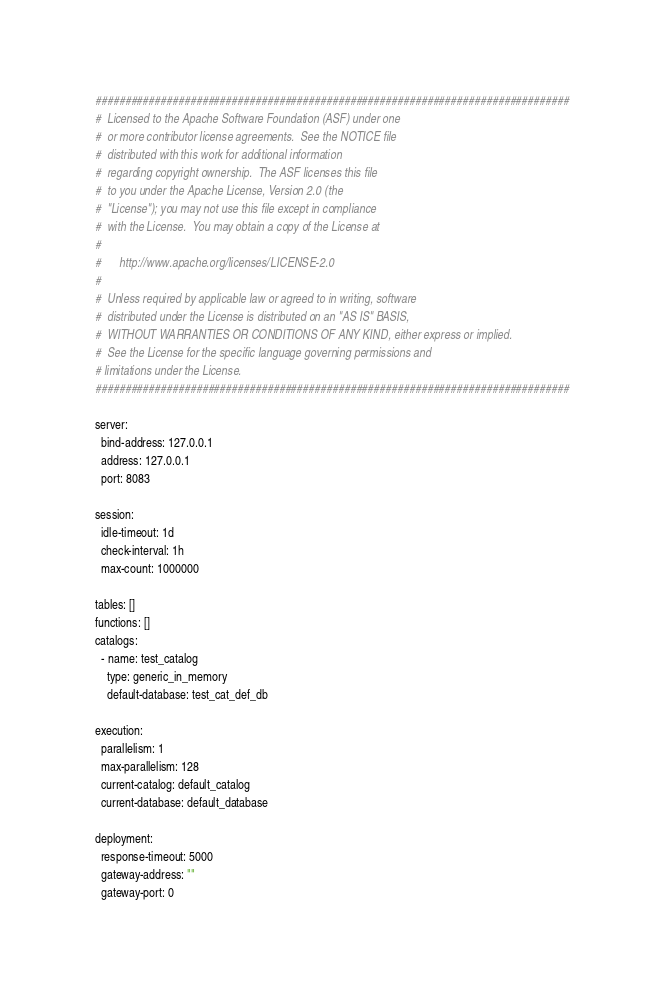Convert code to text. <code><loc_0><loc_0><loc_500><loc_500><_YAML_>################################################################################
#  Licensed to the Apache Software Foundation (ASF) under one
#  or more contributor license agreements.  See the NOTICE file
#  distributed with this work for additional information
#  regarding copyright ownership.  The ASF licenses this file
#  to you under the Apache License, Version 2.0 (the
#  "License"); you may not use this file except in compliance
#  with the License.  You may obtain a copy of the License at
#
#      http://www.apache.org/licenses/LICENSE-2.0
#
#  Unless required by applicable law or agreed to in writing, software
#  distributed under the License is distributed on an "AS IS" BASIS,
#  WITHOUT WARRANTIES OR CONDITIONS OF ANY KIND, either express or implied.
#  See the License for the specific language governing permissions and
# limitations under the License.
################################################################################

server:
  bind-address: 127.0.0.1
  address: 127.0.0.1
  port: 8083

session:
  idle-timeout: 1d
  check-interval: 1h
  max-count: 1000000

tables: []
functions: []
catalogs:
  - name: test_catalog
    type: generic_in_memory
    default-database: test_cat_def_db

execution:
  parallelism: 1
  max-parallelism: 128
  current-catalog: default_catalog
  current-database: default_database

deployment:
  response-timeout: 5000
  gateway-address: ""
  gateway-port: 0
</code> 